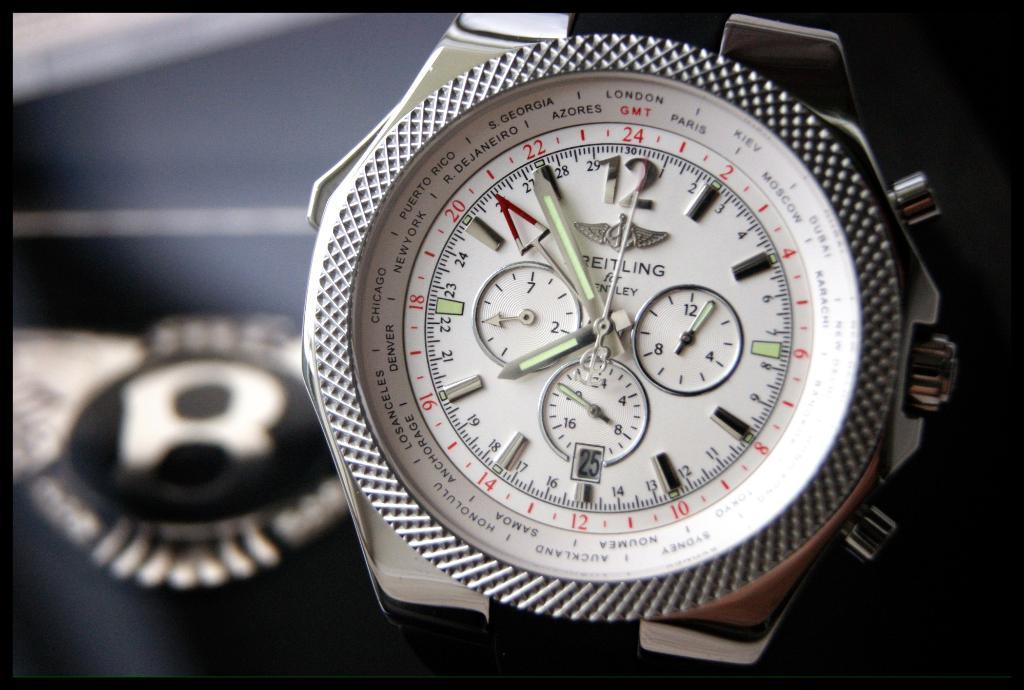<image>
Give a short and clear explanation of the subsequent image. Watch that is made by Reitling for Bentley with different cities and time zones. 